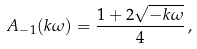Convert formula to latex. <formula><loc_0><loc_0><loc_500><loc_500>A _ { - 1 } ( k \omega ) = \frac { 1 + 2 \sqrt { - k \omega } } { 4 } \, ,</formula> 